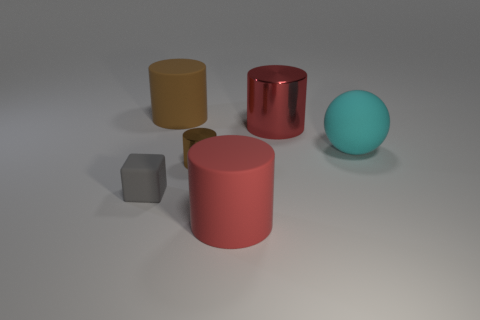Subtract all tiny cylinders. How many cylinders are left? 3 Subtract all brown cylinders. How many cylinders are left? 2 Subtract 1 cylinders. How many cylinders are left? 3 Add 4 small matte objects. How many objects exist? 10 Subtract all blocks. How many objects are left? 5 Subtract all red blocks. Subtract all yellow cylinders. How many blocks are left? 1 Subtract all gray balls. How many red cylinders are left? 2 Subtract all cyan things. Subtract all big brown rubber objects. How many objects are left? 4 Add 6 brown cylinders. How many brown cylinders are left? 8 Add 3 big brown rubber cylinders. How many big brown rubber cylinders exist? 4 